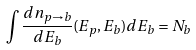<formula> <loc_0><loc_0><loc_500><loc_500>\int \frac { d n _ { p \rightarrow b } } { d E _ { b } } ( E _ { p } , E _ { b } ) d E _ { b } = N _ { b }</formula> 